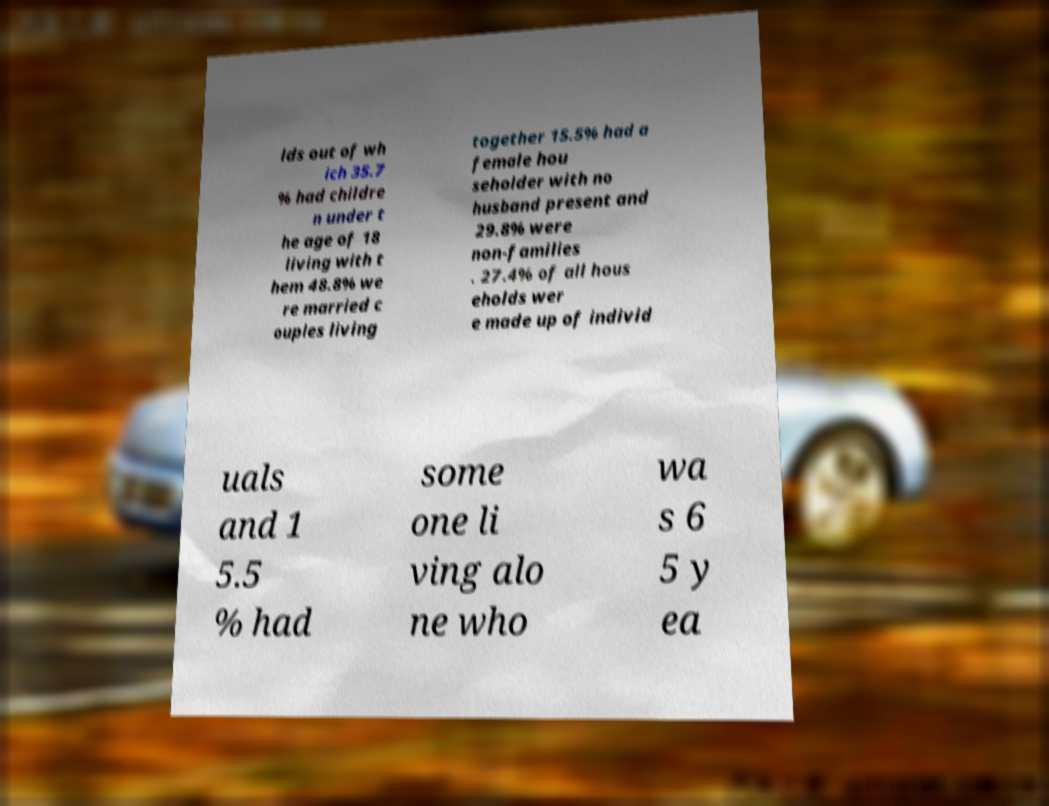Can you accurately transcribe the text from the provided image for me? lds out of wh ich 35.7 % had childre n under t he age of 18 living with t hem 48.8% we re married c ouples living together 15.5% had a female hou seholder with no husband present and 29.8% were non-families . 27.4% of all hous eholds wer e made up of individ uals and 1 5.5 % had some one li ving alo ne who wa s 6 5 y ea 